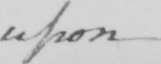Transcribe the text shown in this historical manuscript line. upon 